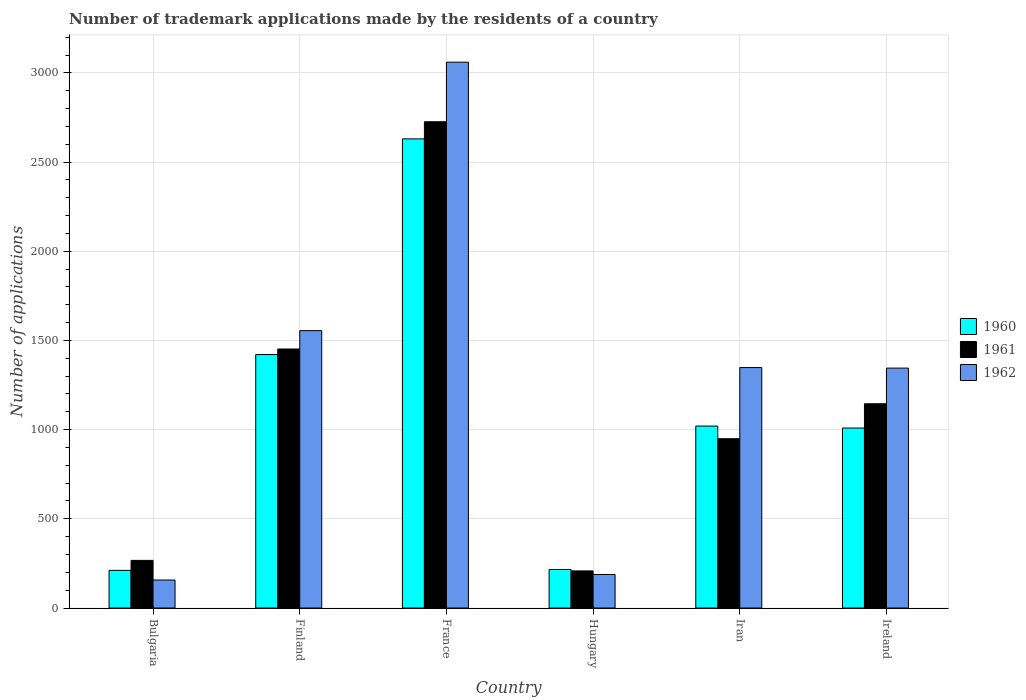How many different coloured bars are there?
Give a very brief answer. 3. How many groups of bars are there?
Your answer should be very brief. 6. Are the number of bars per tick equal to the number of legend labels?
Your answer should be compact. Yes. How many bars are there on the 4th tick from the left?
Your answer should be very brief. 3. How many bars are there on the 6th tick from the right?
Provide a succinct answer. 3. What is the label of the 6th group of bars from the left?
Keep it short and to the point. Ireland. What is the number of trademark applications made by the residents in 1961 in Finland?
Your response must be concise. 1452. Across all countries, what is the maximum number of trademark applications made by the residents in 1960?
Make the answer very short. 2630. Across all countries, what is the minimum number of trademark applications made by the residents in 1961?
Offer a terse response. 208. In which country was the number of trademark applications made by the residents in 1961 maximum?
Your response must be concise. France. In which country was the number of trademark applications made by the residents in 1962 minimum?
Offer a very short reply. Bulgaria. What is the total number of trademark applications made by the residents in 1961 in the graph?
Keep it short and to the point. 6747. What is the difference between the number of trademark applications made by the residents in 1962 in Finland and that in Hungary?
Your answer should be very brief. 1367. What is the difference between the number of trademark applications made by the residents in 1961 in Finland and the number of trademark applications made by the residents in 1962 in Ireland?
Your response must be concise. 107. What is the average number of trademark applications made by the residents in 1961 per country?
Offer a terse response. 1124.5. What is the difference between the number of trademark applications made by the residents of/in 1961 and number of trademark applications made by the residents of/in 1962 in Finland?
Your answer should be very brief. -103. In how many countries, is the number of trademark applications made by the residents in 1962 greater than 2800?
Keep it short and to the point. 1. What is the ratio of the number of trademark applications made by the residents in 1961 in France to that in Iran?
Ensure brevity in your answer.  2.87. Is the difference between the number of trademark applications made by the residents in 1961 in Finland and Iran greater than the difference between the number of trademark applications made by the residents in 1962 in Finland and Iran?
Provide a short and direct response. Yes. What is the difference between the highest and the second highest number of trademark applications made by the residents in 1961?
Your response must be concise. -307. What is the difference between the highest and the lowest number of trademark applications made by the residents in 1962?
Offer a terse response. 2903. In how many countries, is the number of trademark applications made by the residents in 1962 greater than the average number of trademark applications made by the residents in 1962 taken over all countries?
Offer a terse response. 4. Is the sum of the number of trademark applications made by the residents in 1961 in Finland and France greater than the maximum number of trademark applications made by the residents in 1960 across all countries?
Offer a very short reply. Yes. Is it the case that in every country, the sum of the number of trademark applications made by the residents in 1962 and number of trademark applications made by the residents in 1960 is greater than the number of trademark applications made by the residents in 1961?
Your response must be concise. Yes. Are all the bars in the graph horizontal?
Ensure brevity in your answer.  No. What is the difference between two consecutive major ticks on the Y-axis?
Your answer should be compact. 500. Are the values on the major ticks of Y-axis written in scientific E-notation?
Give a very brief answer. No. Does the graph contain any zero values?
Keep it short and to the point. No. What is the title of the graph?
Give a very brief answer. Number of trademark applications made by the residents of a country. Does "1991" appear as one of the legend labels in the graph?
Make the answer very short. No. What is the label or title of the X-axis?
Keep it short and to the point. Country. What is the label or title of the Y-axis?
Your answer should be compact. Number of applications. What is the Number of applications in 1960 in Bulgaria?
Your response must be concise. 211. What is the Number of applications in 1961 in Bulgaria?
Your answer should be very brief. 267. What is the Number of applications of 1962 in Bulgaria?
Offer a very short reply. 157. What is the Number of applications in 1960 in Finland?
Provide a succinct answer. 1421. What is the Number of applications in 1961 in Finland?
Give a very brief answer. 1452. What is the Number of applications in 1962 in Finland?
Provide a succinct answer. 1555. What is the Number of applications of 1960 in France?
Keep it short and to the point. 2630. What is the Number of applications of 1961 in France?
Offer a very short reply. 2726. What is the Number of applications of 1962 in France?
Your answer should be very brief. 3060. What is the Number of applications of 1960 in Hungary?
Ensure brevity in your answer.  216. What is the Number of applications in 1961 in Hungary?
Provide a short and direct response. 208. What is the Number of applications of 1962 in Hungary?
Provide a short and direct response. 188. What is the Number of applications in 1960 in Iran?
Your answer should be very brief. 1020. What is the Number of applications in 1961 in Iran?
Your answer should be compact. 949. What is the Number of applications in 1962 in Iran?
Provide a short and direct response. 1348. What is the Number of applications in 1960 in Ireland?
Give a very brief answer. 1009. What is the Number of applications of 1961 in Ireland?
Provide a succinct answer. 1145. What is the Number of applications in 1962 in Ireland?
Your answer should be very brief. 1345. Across all countries, what is the maximum Number of applications of 1960?
Offer a very short reply. 2630. Across all countries, what is the maximum Number of applications of 1961?
Your answer should be compact. 2726. Across all countries, what is the maximum Number of applications of 1962?
Provide a short and direct response. 3060. Across all countries, what is the minimum Number of applications of 1960?
Your answer should be compact. 211. Across all countries, what is the minimum Number of applications in 1961?
Ensure brevity in your answer.  208. Across all countries, what is the minimum Number of applications of 1962?
Provide a succinct answer. 157. What is the total Number of applications of 1960 in the graph?
Your response must be concise. 6507. What is the total Number of applications in 1961 in the graph?
Make the answer very short. 6747. What is the total Number of applications of 1962 in the graph?
Your answer should be very brief. 7653. What is the difference between the Number of applications in 1960 in Bulgaria and that in Finland?
Make the answer very short. -1210. What is the difference between the Number of applications of 1961 in Bulgaria and that in Finland?
Offer a terse response. -1185. What is the difference between the Number of applications in 1962 in Bulgaria and that in Finland?
Your response must be concise. -1398. What is the difference between the Number of applications in 1960 in Bulgaria and that in France?
Offer a very short reply. -2419. What is the difference between the Number of applications in 1961 in Bulgaria and that in France?
Make the answer very short. -2459. What is the difference between the Number of applications in 1962 in Bulgaria and that in France?
Provide a short and direct response. -2903. What is the difference between the Number of applications in 1960 in Bulgaria and that in Hungary?
Provide a short and direct response. -5. What is the difference between the Number of applications in 1961 in Bulgaria and that in Hungary?
Your response must be concise. 59. What is the difference between the Number of applications of 1962 in Bulgaria and that in Hungary?
Your answer should be very brief. -31. What is the difference between the Number of applications in 1960 in Bulgaria and that in Iran?
Ensure brevity in your answer.  -809. What is the difference between the Number of applications of 1961 in Bulgaria and that in Iran?
Offer a very short reply. -682. What is the difference between the Number of applications of 1962 in Bulgaria and that in Iran?
Make the answer very short. -1191. What is the difference between the Number of applications of 1960 in Bulgaria and that in Ireland?
Your response must be concise. -798. What is the difference between the Number of applications in 1961 in Bulgaria and that in Ireland?
Provide a succinct answer. -878. What is the difference between the Number of applications of 1962 in Bulgaria and that in Ireland?
Provide a short and direct response. -1188. What is the difference between the Number of applications of 1960 in Finland and that in France?
Provide a succinct answer. -1209. What is the difference between the Number of applications of 1961 in Finland and that in France?
Ensure brevity in your answer.  -1274. What is the difference between the Number of applications in 1962 in Finland and that in France?
Your answer should be very brief. -1505. What is the difference between the Number of applications of 1960 in Finland and that in Hungary?
Give a very brief answer. 1205. What is the difference between the Number of applications of 1961 in Finland and that in Hungary?
Offer a terse response. 1244. What is the difference between the Number of applications in 1962 in Finland and that in Hungary?
Your answer should be compact. 1367. What is the difference between the Number of applications in 1960 in Finland and that in Iran?
Your response must be concise. 401. What is the difference between the Number of applications in 1961 in Finland and that in Iran?
Your answer should be very brief. 503. What is the difference between the Number of applications in 1962 in Finland and that in Iran?
Your answer should be compact. 207. What is the difference between the Number of applications of 1960 in Finland and that in Ireland?
Provide a succinct answer. 412. What is the difference between the Number of applications of 1961 in Finland and that in Ireland?
Give a very brief answer. 307. What is the difference between the Number of applications in 1962 in Finland and that in Ireland?
Make the answer very short. 210. What is the difference between the Number of applications of 1960 in France and that in Hungary?
Ensure brevity in your answer.  2414. What is the difference between the Number of applications in 1961 in France and that in Hungary?
Provide a short and direct response. 2518. What is the difference between the Number of applications of 1962 in France and that in Hungary?
Offer a terse response. 2872. What is the difference between the Number of applications in 1960 in France and that in Iran?
Your answer should be compact. 1610. What is the difference between the Number of applications in 1961 in France and that in Iran?
Your answer should be very brief. 1777. What is the difference between the Number of applications of 1962 in France and that in Iran?
Make the answer very short. 1712. What is the difference between the Number of applications of 1960 in France and that in Ireland?
Provide a short and direct response. 1621. What is the difference between the Number of applications of 1961 in France and that in Ireland?
Your response must be concise. 1581. What is the difference between the Number of applications of 1962 in France and that in Ireland?
Your answer should be very brief. 1715. What is the difference between the Number of applications in 1960 in Hungary and that in Iran?
Offer a terse response. -804. What is the difference between the Number of applications of 1961 in Hungary and that in Iran?
Your answer should be very brief. -741. What is the difference between the Number of applications of 1962 in Hungary and that in Iran?
Provide a succinct answer. -1160. What is the difference between the Number of applications of 1960 in Hungary and that in Ireland?
Offer a terse response. -793. What is the difference between the Number of applications of 1961 in Hungary and that in Ireland?
Give a very brief answer. -937. What is the difference between the Number of applications of 1962 in Hungary and that in Ireland?
Provide a short and direct response. -1157. What is the difference between the Number of applications in 1960 in Iran and that in Ireland?
Ensure brevity in your answer.  11. What is the difference between the Number of applications in 1961 in Iran and that in Ireland?
Give a very brief answer. -196. What is the difference between the Number of applications in 1960 in Bulgaria and the Number of applications in 1961 in Finland?
Make the answer very short. -1241. What is the difference between the Number of applications of 1960 in Bulgaria and the Number of applications of 1962 in Finland?
Provide a short and direct response. -1344. What is the difference between the Number of applications in 1961 in Bulgaria and the Number of applications in 1962 in Finland?
Keep it short and to the point. -1288. What is the difference between the Number of applications of 1960 in Bulgaria and the Number of applications of 1961 in France?
Ensure brevity in your answer.  -2515. What is the difference between the Number of applications of 1960 in Bulgaria and the Number of applications of 1962 in France?
Your answer should be very brief. -2849. What is the difference between the Number of applications in 1961 in Bulgaria and the Number of applications in 1962 in France?
Offer a terse response. -2793. What is the difference between the Number of applications in 1960 in Bulgaria and the Number of applications in 1961 in Hungary?
Offer a very short reply. 3. What is the difference between the Number of applications in 1960 in Bulgaria and the Number of applications in 1962 in Hungary?
Keep it short and to the point. 23. What is the difference between the Number of applications of 1961 in Bulgaria and the Number of applications of 1962 in Hungary?
Your answer should be compact. 79. What is the difference between the Number of applications in 1960 in Bulgaria and the Number of applications in 1961 in Iran?
Your answer should be compact. -738. What is the difference between the Number of applications of 1960 in Bulgaria and the Number of applications of 1962 in Iran?
Offer a very short reply. -1137. What is the difference between the Number of applications in 1961 in Bulgaria and the Number of applications in 1962 in Iran?
Provide a succinct answer. -1081. What is the difference between the Number of applications of 1960 in Bulgaria and the Number of applications of 1961 in Ireland?
Offer a very short reply. -934. What is the difference between the Number of applications in 1960 in Bulgaria and the Number of applications in 1962 in Ireland?
Provide a short and direct response. -1134. What is the difference between the Number of applications of 1961 in Bulgaria and the Number of applications of 1962 in Ireland?
Offer a terse response. -1078. What is the difference between the Number of applications of 1960 in Finland and the Number of applications of 1961 in France?
Your answer should be compact. -1305. What is the difference between the Number of applications in 1960 in Finland and the Number of applications in 1962 in France?
Make the answer very short. -1639. What is the difference between the Number of applications of 1961 in Finland and the Number of applications of 1962 in France?
Your answer should be very brief. -1608. What is the difference between the Number of applications in 1960 in Finland and the Number of applications in 1961 in Hungary?
Ensure brevity in your answer.  1213. What is the difference between the Number of applications of 1960 in Finland and the Number of applications of 1962 in Hungary?
Provide a succinct answer. 1233. What is the difference between the Number of applications in 1961 in Finland and the Number of applications in 1962 in Hungary?
Provide a succinct answer. 1264. What is the difference between the Number of applications in 1960 in Finland and the Number of applications in 1961 in Iran?
Give a very brief answer. 472. What is the difference between the Number of applications of 1961 in Finland and the Number of applications of 1962 in Iran?
Your answer should be very brief. 104. What is the difference between the Number of applications of 1960 in Finland and the Number of applications of 1961 in Ireland?
Offer a terse response. 276. What is the difference between the Number of applications of 1961 in Finland and the Number of applications of 1962 in Ireland?
Keep it short and to the point. 107. What is the difference between the Number of applications of 1960 in France and the Number of applications of 1961 in Hungary?
Give a very brief answer. 2422. What is the difference between the Number of applications in 1960 in France and the Number of applications in 1962 in Hungary?
Make the answer very short. 2442. What is the difference between the Number of applications of 1961 in France and the Number of applications of 1962 in Hungary?
Your response must be concise. 2538. What is the difference between the Number of applications of 1960 in France and the Number of applications of 1961 in Iran?
Give a very brief answer. 1681. What is the difference between the Number of applications in 1960 in France and the Number of applications in 1962 in Iran?
Provide a short and direct response. 1282. What is the difference between the Number of applications of 1961 in France and the Number of applications of 1962 in Iran?
Your answer should be compact. 1378. What is the difference between the Number of applications of 1960 in France and the Number of applications of 1961 in Ireland?
Offer a very short reply. 1485. What is the difference between the Number of applications in 1960 in France and the Number of applications in 1962 in Ireland?
Your answer should be compact. 1285. What is the difference between the Number of applications of 1961 in France and the Number of applications of 1962 in Ireland?
Give a very brief answer. 1381. What is the difference between the Number of applications in 1960 in Hungary and the Number of applications in 1961 in Iran?
Ensure brevity in your answer.  -733. What is the difference between the Number of applications of 1960 in Hungary and the Number of applications of 1962 in Iran?
Make the answer very short. -1132. What is the difference between the Number of applications in 1961 in Hungary and the Number of applications in 1962 in Iran?
Your answer should be very brief. -1140. What is the difference between the Number of applications in 1960 in Hungary and the Number of applications in 1961 in Ireland?
Make the answer very short. -929. What is the difference between the Number of applications in 1960 in Hungary and the Number of applications in 1962 in Ireland?
Your answer should be very brief. -1129. What is the difference between the Number of applications of 1961 in Hungary and the Number of applications of 1962 in Ireland?
Your answer should be compact. -1137. What is the difference between the Number of applications in 1960 in Iran and the Number of applications in 1961 in Ireland?
Give a very brief answer. -125. What is the difference between the Number of applications in 1960 in Iran and the Number of applications in 1962 in Ireland?
Keep it short and to the point. -325. What is the difference between the Number of applications of 1961 in Iran and the Number of applications of 1962 in Ireland?
Your answer should be very brief. -396. What is the average Number of applications in 1960 per country?
Give a very brief answer. 1084.5. What is the average Number of applications of 1961 per country?
Offer a terse response. 1124.5. What is the average Number of applications of 1962 per country?
Offer a very short reply. 1275.5. What is the difference between the Number of applications of 1960 and Number of applications of 1961 in Bulgaria?
Provide a short and direct response. -56. What is the difference between the Number of applications of 1961 and Number of applications of 1962 in Bulgaria?
Give a very brief answer. 110. What is the difference between the Number of applications of 1960 and Number of applications of 1961 in Finland?
Make the answer very short. -31. What is the difference between the Number of applications in 1960 and Number of applications in 1962 in Finland?
Make the answer very short. -134. What is the difference between the Number of applications of 1961 and Number of applications of 1962 in Finland?
Your response must be concise. -103. What is the difference between the Number of applications of 1960 and Number of applications of 1961 in France?
Your response must be concise. -96. What is the difference between the Number of applications in 1960 and Number of applications in 1962 in France?
Make the answer very short. -430. What is the difference between the Number of applications of 1961 and Number of applications of 1962 in France?
Offer a terse response. -334. What is the difference between the Number of applications in 1960 and Number of applications in 1961 in Hungary?
Your response must be concise. 8. What is the difference between the Number of applications of 1960 and Number of applications of 1962 in Hungary?
Provide a short and direct response. 28. What is the difference between the Number of applications in 1961 and Number of applications in 1962 in Hungary?
Provide a short and direct response. 20. What is the difference between the Number of applications of 1960 and Number of applications of 1962 in Iran?
Provide a succinct answer. -328. What is the difference between the Number of applications in 1961 and Number of applications in 1962 in Iran?
Your answer should be compact. -399. What is the difference between the Number of applications in 1960 and Number of applications in 1961 in Ireland?
Provide a succinct answer. -136. What is the difference between the Number of applications in 1960 and Number of applications in 1962 in Ireland?
Offer a very short reply. -336. What is the difference between the Number of applications in 1961 and Number of applications in 1962 in Ireland?
Keep it short and to the point. -200. What is the ratio of the Number of applications of 1960 in Bulgaria to that in Finland?
Your answer should be very brief. 0.15. What is the ratio of the Number of applications of 1961 in Bulgaria to that in Finland?
Your answer should be very brief. 0.18. What is the ratio of the Number of applications of 1962 in Bulgaria to that in Finland?
Give a very brief answer. 0.1. What is the ratio of the Number of applications in 1960 in Bulgaria to that in France?
Provide a succinct answer. 0.08. What is the ratio of the Number of applications of 1961 in Bulgaria to that in France?
Give a very brief answer. 0.1. What is the ratio of the Number of applications of 1962 in Bulgaria to that in France?
Offer a very short reply. 0.05. What is the ratio of the Number of applications in 1960 in Bulgaria to that in Hungary?
Ensure brevity in your answer.  0.98. What is the ratio of the Number of applications in 1961 in Bulgaria to that in Hungary?
Your response must be concise. 1.28. What is the ratio of the Number of applications in 1962 in Bulgaria to that in Hungary?
Offer a very short reply. 0.84. What is the ratio of the Number of applications in 1960 in Bulgaria to that in Iran?
Make the answer very short. 0.21. What is the ratio of the Number of applications in 1961 in Bulgaria to that in Iran?
Give a very brief answer. 0.28. What is the ratio of the Number of applications of 1962 in Bulgaria to that in Iran?
Give a very brief answer. 0.12. What is the ratio of the Number of applications in 1960 in Bulgaria to that in Ireland?
Your answer should be compact. 0.21. What is the ratio of the Number of applications in 1961 in Bulgaria to that in Ireland?
Provide a short and direct response. 0.23. What is the ratio of the Number of applications of 1962 in Bulgaria to that in Ireland?
Keep it short and to the point. 0.12. What is the ratio of the Number of applications in 1960 in Finland to that in France?
Keep it short and to the point. 0.54. What is the ratio of the Number of applications of 1961 in Finland to that in France?
Your answer should be very brief. 0.53. What is the ratio of the Number of applications of 1962 in Finland to that in France?
Your answer should be compact. 0.51. What is the ratio of the Number of applications in 1960 in Finland to that in Hungary?
Your response must be concise. 6.58. What is the ratio of the Number of applications in 1961 in Finland to that in Hungary?
Provide a short and direct response. 6.98. What is the ratio of the Number of applications in 1962 in Finland to that in Hungary?
Your answer should be compact. 8.27. What is the ratio of the Number of applications of 1960 in Finland to that in Iran?
Your answer should be very brief. 1.39. What is the ratio of the Number of applications of 1961 in Finland to that in Iran?
Provide a succinct answer. 1.53. What is the ratio of the Number of applications in 1962 in Finland to that in Iran?
Provide a short and direct response. 1.15. What is the ratio of the Number of applications in 1960 in Finland to that in Ireland?
Keep it short and to the point. 1.41. What is the ratio of the Number of applications of 1961 in Finland to that in Ireland?
Keep it short and to the point. 1.27. What is the ratio of the Number of applications of 1962 in Finland to that in Ireland?
Offer a terse response. 1.16. What is the ratio of the Number of applications of 1960 in France to that in Hungary?
Offer a very short reply. 12.18. What is the ratio of the Number of applications of 1961 in France to that in Hungary?
Ensure brevity in your answer.  13.11. What is the ratio of the Number of applications of 1962 in France to that in Hungary?
Offer a very short reply. 16.28. What is the ratio of the Number of applications in 1960 in France to that in Iran?
Keep it short and to the point. 2.58. What is the ratio of the Number of applications in 1961 in France to that in Iran?
Make the answer very short. 2.87. What is the ratio of the Number of applications in 1962 in France to that in Iran?
Make the answer very short. 2.27. What is the ratio of the Number of applications of 1960 in France to that in Ireland?
Your answer should be compact. 2.61. What is the ratio of the Number of applications in 1961 in France to that in Ireland?
Give a very brief answer. 2.38. What is the ratio of the Number of applications in 1962 in France to that in Ireland?
Give a very brief answer. 2.28. What is the ratio of the Number of applications of 1960 in Hungary to that in Iran?
Keep it short and to the point. 0.21. What is the ratio of the Number of applications in 1961 in Hungary to that in Iran?
Make the answer very short. 0.22. What is the ratio of the Number of applications in 1962 in Hungary to that in Iran?
Ensure brevity in your answer.  0.14. What is the ratio of the Number of applications of 1960 in Hungary to that in Ireland?
Your answer should be very brief. 0.21. What is the ratio of the Number of applications in 1961 in Hungary to that in Ireland?
Keep it short and to the point. 0.18. What is the ratio of the Number of applications in 1962 in Hungary to that in Ireland?
Offer a terse response. 0.14. What is the ratio of the Number of applications in 1960 in Iran to that in Ireland?
Your answer should be compact. 1.01. What is the ratio of the Number of applications of 1961 in Iran to that in Ireland?
Offer a terse response. 0.83. What is the difference between the highest and the second highest Number of applications of 1960?
Keep it short and to the point. 1209. What is the difference between the highest and the second highest Number of applications in 1961?
Give a very brief answer. 1274. What is the difference between the highest and the second highest Number of applications of 1962?
Keep it short and to the point. 1505. What is the difference between the highest and the lowest Number of applications in 1960?
Make the answer very short. 2419. What is the difference between the highest and the lowest Number of applications of 1961?
Offer a very short reply. 2518. What is the difference between the highest and the lowest Number of applications in 1962?
Keep it short and to the point. 2903. 